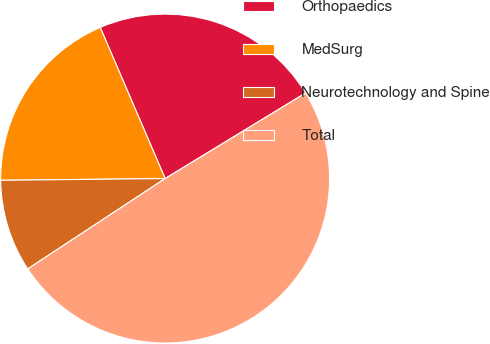<chart> <loc_0><loc_0><loc_500><loc_500><pie_chart><fcel>Orthopaedics<fcel>MedSurg<fcel>Neurotechnology and Spine<fcel>Total<nl><fcel>22.75%<fcel>18.71%<fcel>9.09%<fcel>49.45%<nl></chart> 